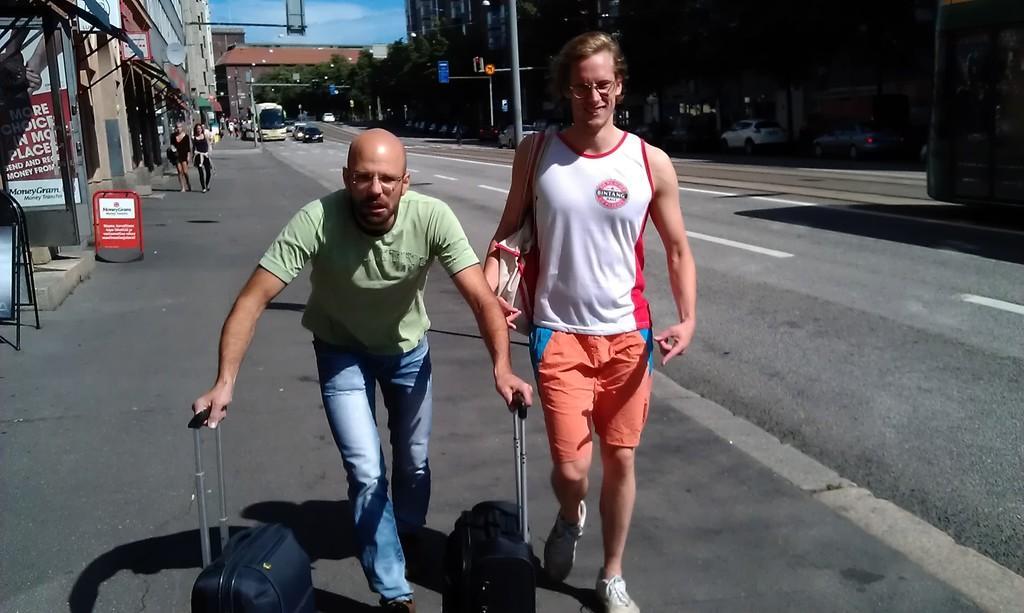Can you describe this image briefly? In the foreground I can see two persons are holding bags in their hand are walking on the road. In the background I can see boards, buildings, shops, posters, light poles, vehicles on the road, trees, crowd and the sky. This image is taken may be during a day. 